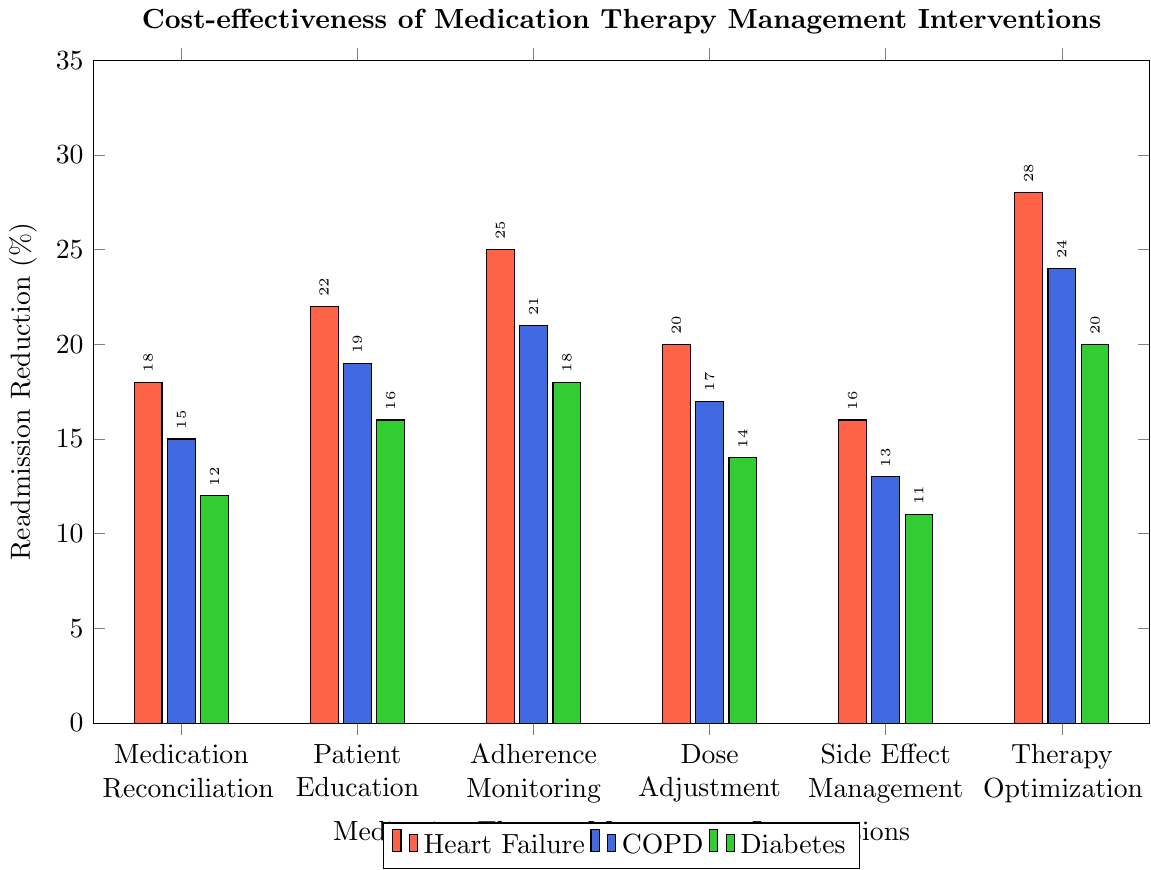What's the best intervention for reducing hospital readmissions for heart failure? The bar representing Therapy Optimization for heart failure reaches the highest point on the chart, at 28%.
Answer: Therapy Optimization Which condition benefits the most from Adherence Monitoring in terms of readmission reduction? Among the three conditions (Heart Failure, COPD, and Diabetes), Heart Failure has the highest readmission reduction at 25% for Adherence Monitoring.
Answer: Heart Failure By how much do Therapy Optimization interventions reduce readmissions, on average, across all conditions? Therapy Optimization reduces readmissions by 28% (Heart Failure), 24% (COPD), and 20% (Diabetes). The average reduction is calculated as (28 + 24 + 20) / 3 = 24%.
Answer: 24% Which intervention shows the smallest readmission reduction for COPD, and what is the value? The lowest bar for COPD is seen with Side Effect Management, which reduces readmissions by 13%.
Answer: Side Effect Management, 13% Is Patient Education more effective in reducing readmissions for Diabetes or COPD? For Diabetes, Patient Education reduces readmissions by 16%, whereas for COPD, the reduction is 19%.
Answer: COPD How much more effective is Adherence Monitoring in reducing readmissions for COPD compared to Dose Adjustment for the same condition? Adherence Monitoring reduces readmissions by 21% for COPD while Dose Adjustment reduces them by 17%. The difference is 21 - 17 = 4%.
Answer: 4% Which intervention shows a higher readmission reduction for Heart Failure compared to the same intervention for Diabetes, and by how much? Therapy Optimization reduces readmissions by 28% for Heart Failure and 20% for Diabetes, so the difference is 28 - 20 = 8%.
Answer: Therapy Optimization, 8% What is the range of readmission reduction percentages for Dose Adjustment across all conditions? For Dose Adjustment, the readmission reductions are 20% (Heart Failure), 17% (COPD), and 14% (Diabetes). The range is the difference between the highest and lowest values: 20 - 14 = 6%.
Answer: 6% Compare the effectiveness of Medication Reconciliation and Patient Education for COPD in terms of readmission reduction. Medication Reconciliation reduces readmissions by 15% for COPD, while Patient Education reduces them by 19%. Patient Education is more effective.
Answer: Patient Education What is the highest readmission reduction percentage observed in the figure, and for which condition and intervention does it occur? The highest readmission reduction percentage is 28%, observed for Therapy Optimization intervention for Heart Failure.
Answer: 28%, Heart Failure, Therapy Optimization 